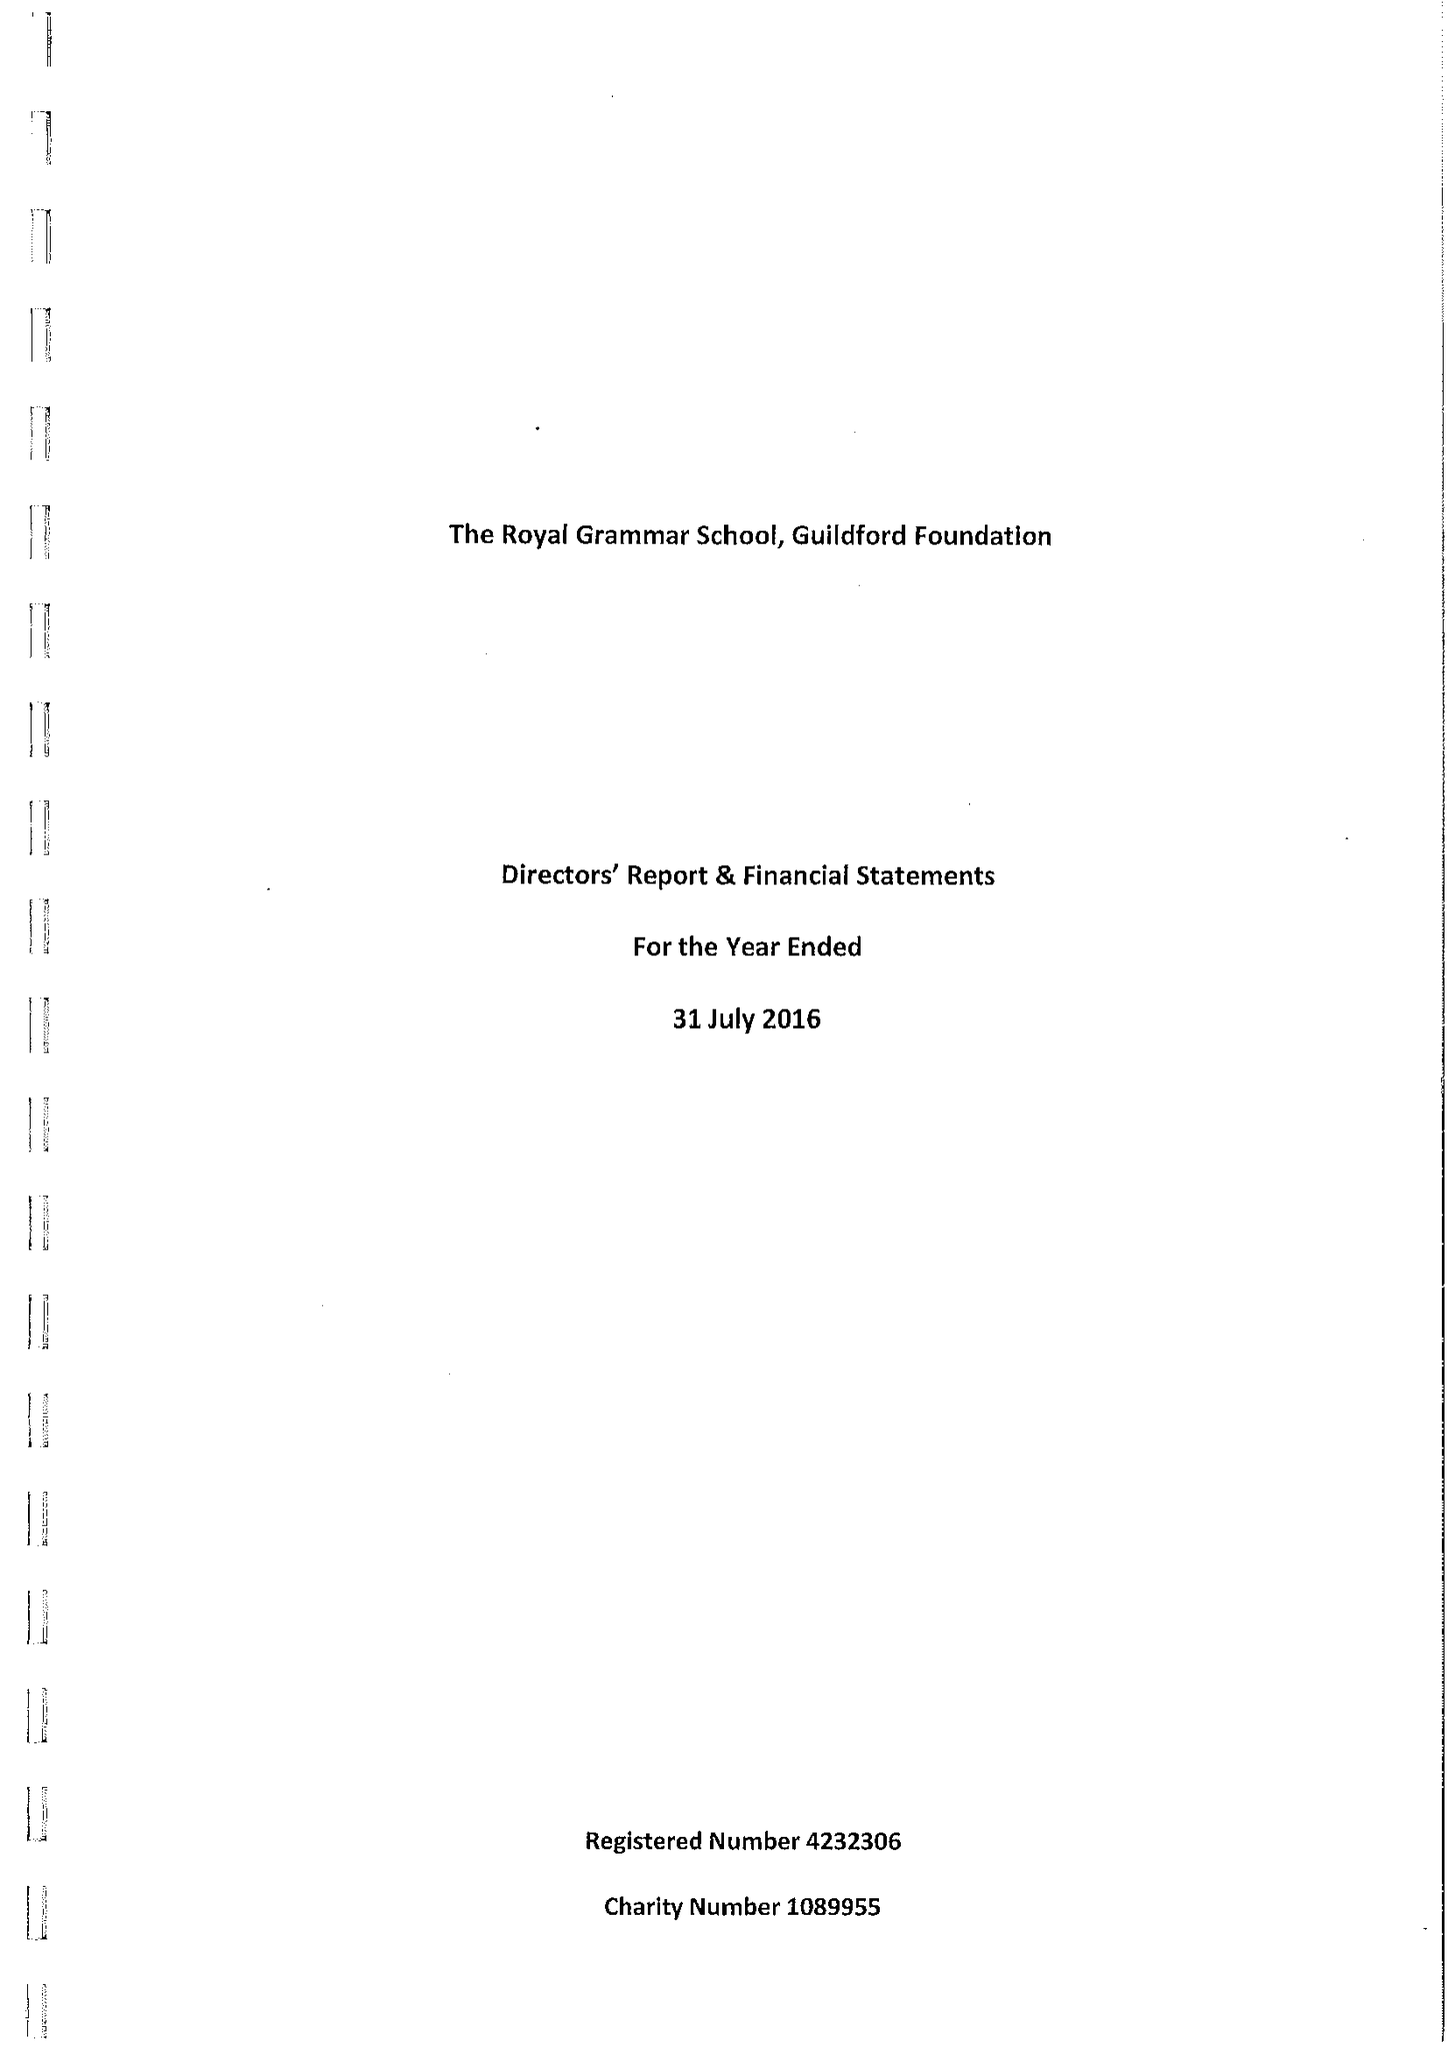What is the value for the address__street_line?
Answer the question using a single word or phrase. HIGH STREET 